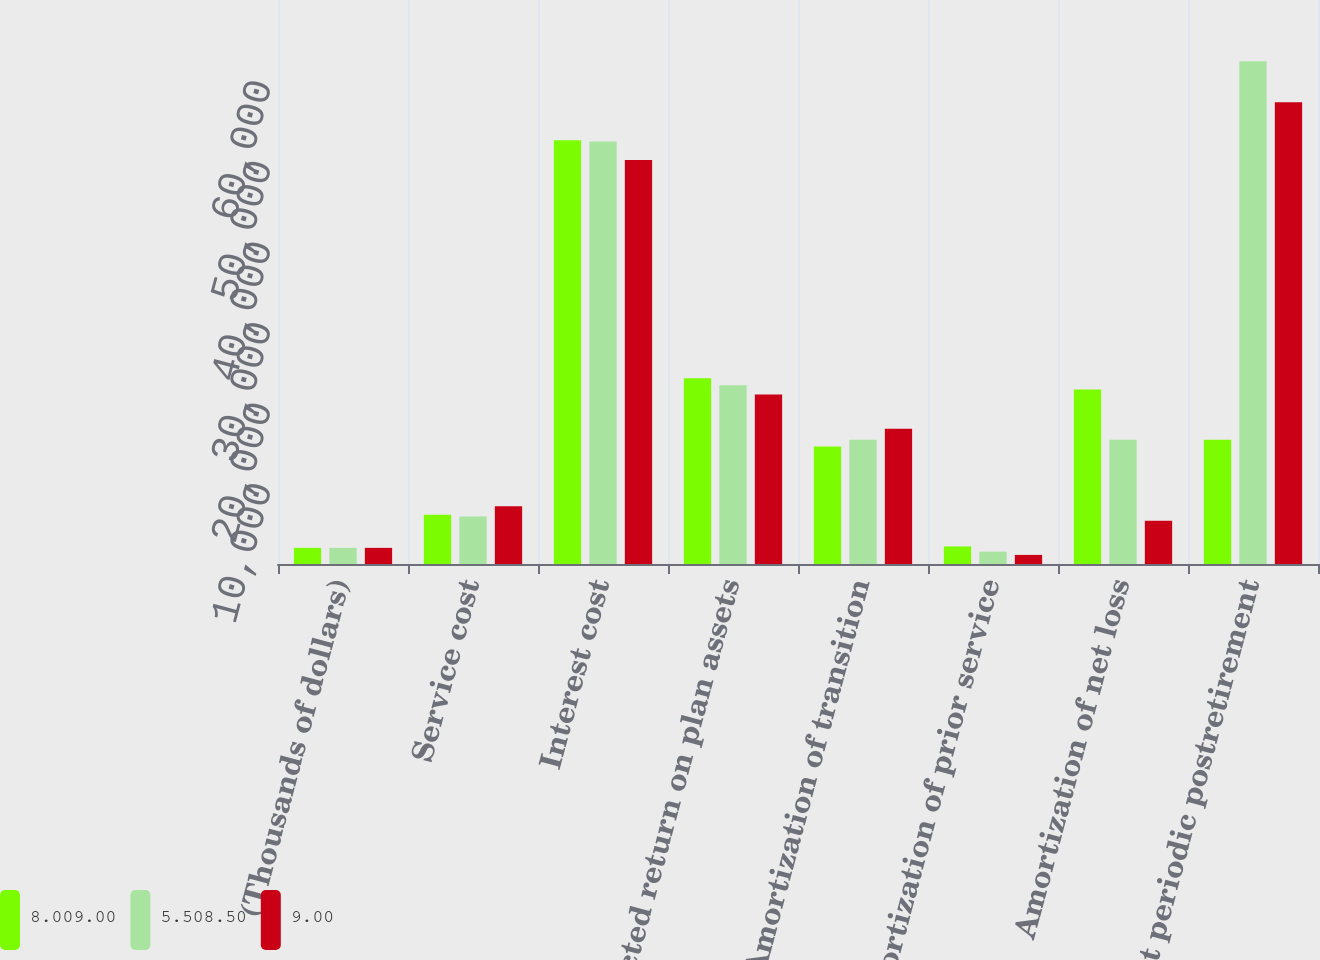<chart> <loc_0><loc_0><loc_500><loc_500><stacked_bar_chart><ecel><fcel>(Thousands of dollars)<fcel>Service cost<fcel>Interest cost<fcel>Expected return on plan assets<fcel>Amortization of transition<fcel>Amortization of prior service<fcel>Amortization of net loss<fcel>Net periodic postretirement<nl><fcel>8.009.00<fcel>2004<fcel>6100<fcel>52604<fcel>23066<fcel>14578<fcel>2179<fcel>21651<fcel>15409<nl><fcel>5.508.50<fcel>2003<fcel>5893<fcel>52426<fcel>22185<fcel>15426<fcel>1533<fcel>15409<fcel>62392<nl><fcel>9.00<fcel>2002<fcel>7173<fcel>50135<fcel>21030<fcel>16771<fcel>1130<fcel>5380<fcel>57299<nl></chart> 